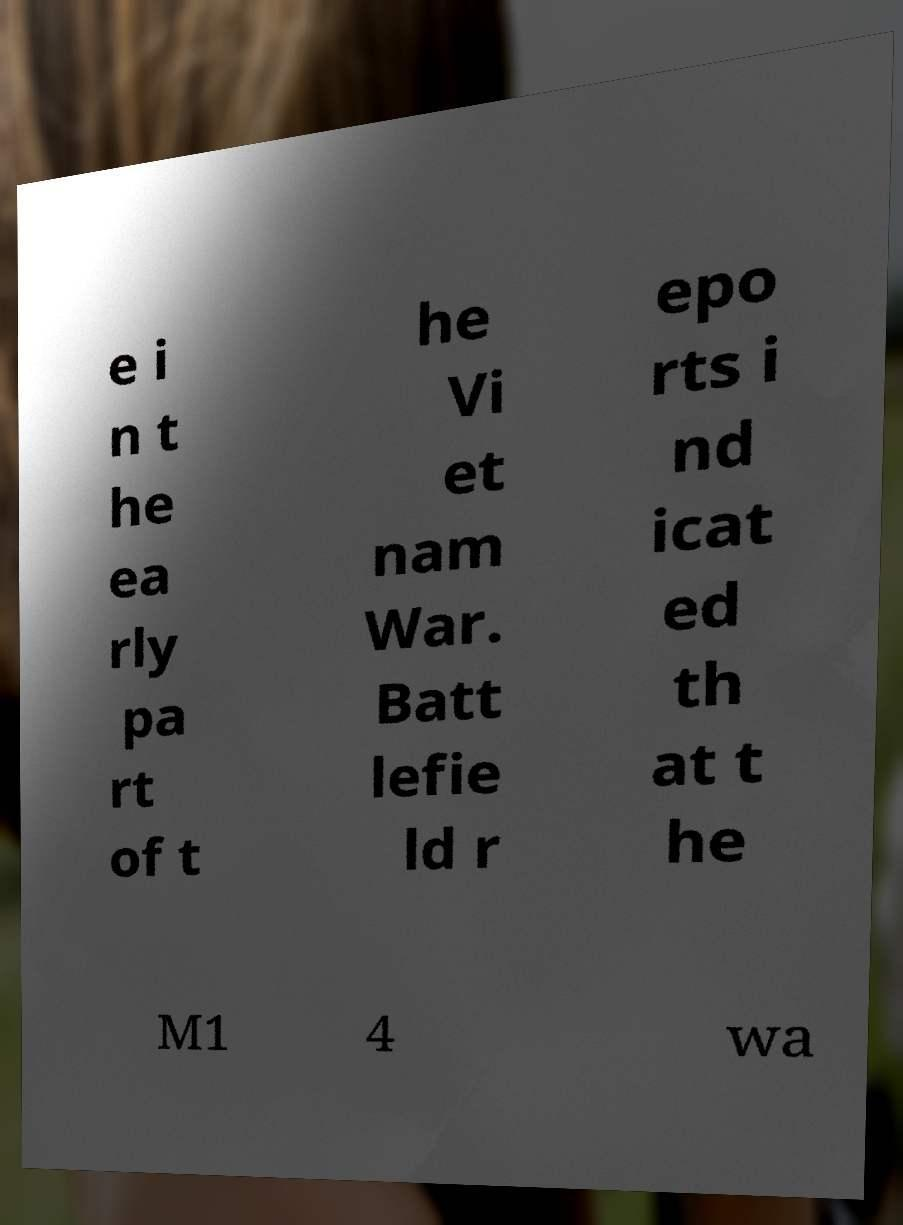Can you read and provide the text displayed in the image?This photo seems to have some interesting text. Can you extract and type it out for me? e i n t he ea rly pa rt of t he Vi et nam War. Batt lefie ld r epo rts i nd icat ed th at t he M1 4 wa 